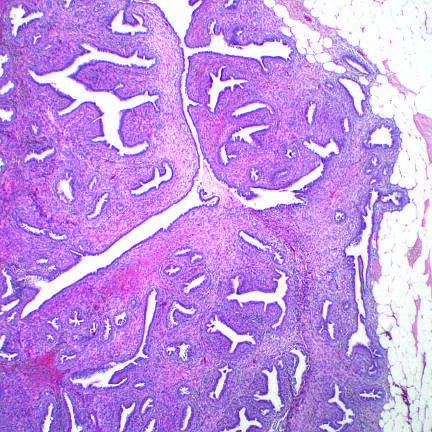what do proliferating stromal cells distort?
Answer the question using a single word or phrase. The glandular tissue 